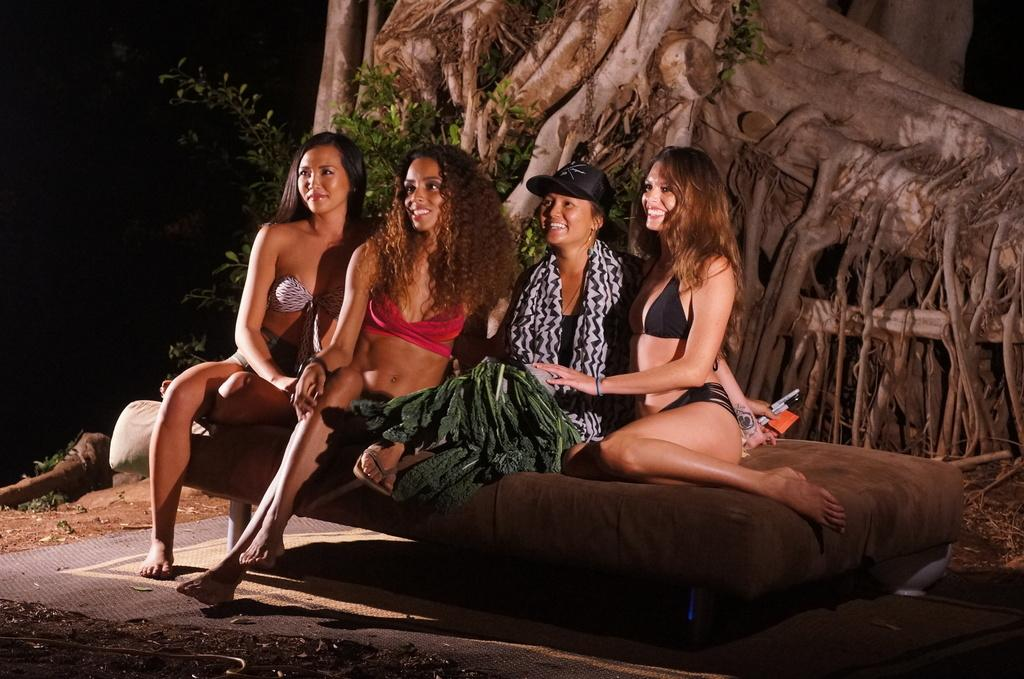What are the women in the image doing? The women in the image are seated on the bed. Can you describe the clothing or accessories of one of the women? One woman is wearing a cap on her head. What can be seen in the background of the image? There are trees visible in the background. What type of brake system can be seen on the trees in the image? There is no brake system present in the image; it features women seated on a bed with trees visible in the background. 